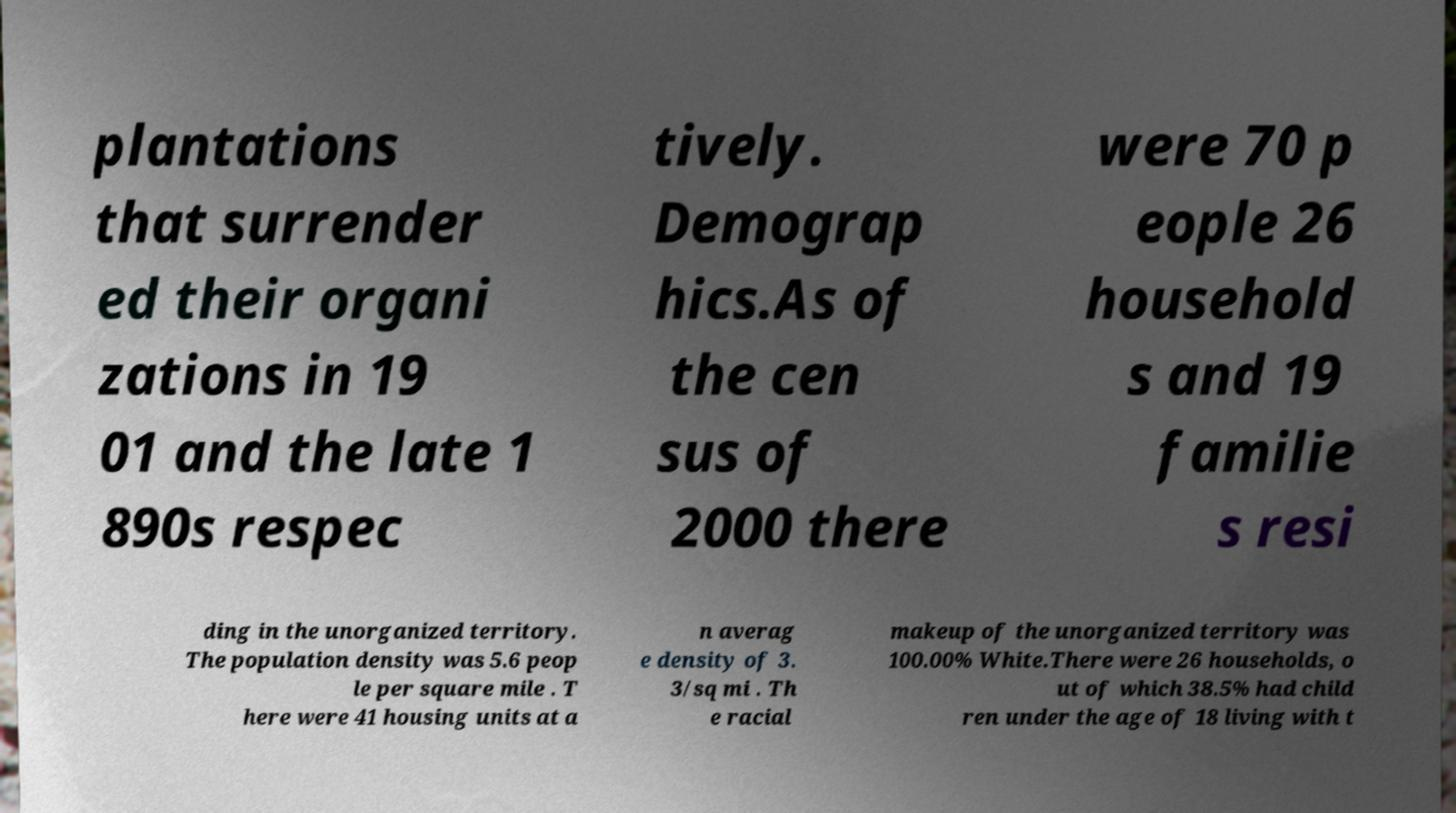Please read and relay the text visible in this image. What does it say? plantations that surrender ed their organi zations in 19 01 and the late 1 890s respec tively. Demograp hics.As of the cen sus of 2000 there were 70 p eople 26 household s and 19 familie s resi ding in the unorganized territory. The population density was 5.6 peop le per square mile . T here were 41 housing units at a n averag e density of 3. 3/sq mi . Th e racial makeup of the unorganized territory was 100.00% White.There were 26 households, o ut of which 38.5% had child ren under the age of 18 living with t 